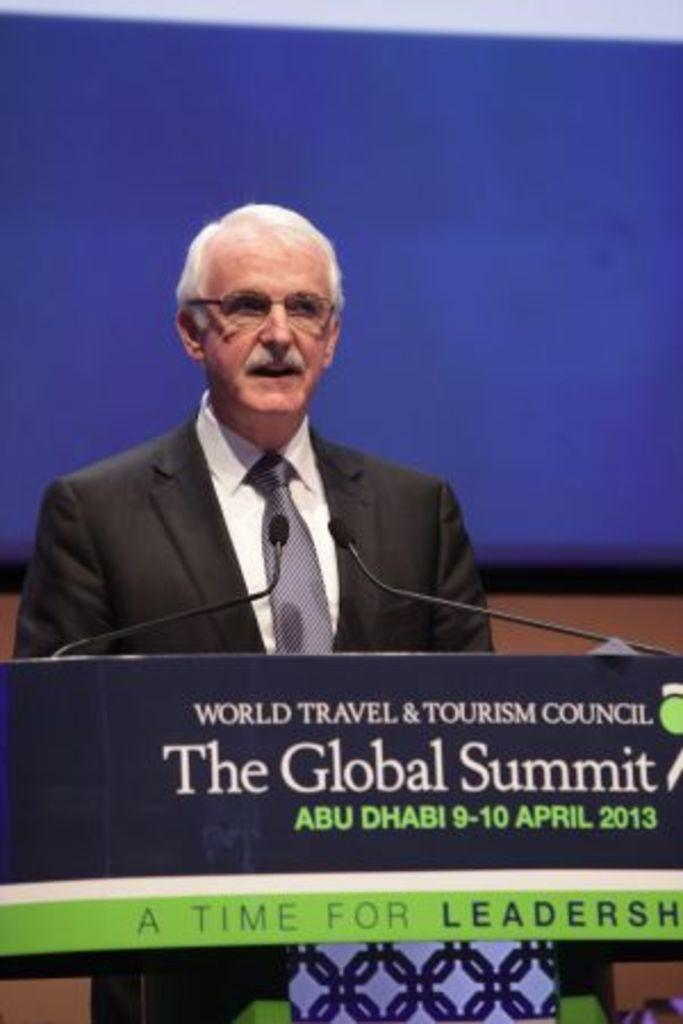What is the man in the image doing? The man is standing and talking in the image. What objects are present that might be related to the man's activity? There are microphones in the image, which suggests that the man is giving a speech or presentation. What is on the podium in the image? There is a board on a podium in the image. What can be seen on the board? There is text on the board. What can be seen in the background of the image? There appears to be a screen in the background of the image. What type of tin can be seen on the podium in the image? There is no tin present on the podium in the image; there is a board with text on it. 